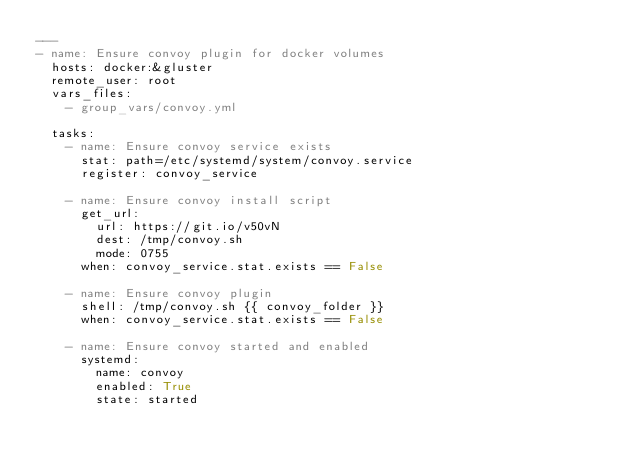<code> <loc_0><loc_0><loc_500><loc_500><_YAML_>---
- name: Ensure convoy plugin for docker volumes
  hosts: docker:&gluster
  remote_user: root
  vars_files:
    - group_vars/convoy.yml
    
  tasks:
    - name: Ensure convoy service exists
      stat: path=/etc/systemd/system/convoy.service
      register: convoy_service
    
    - name: Ensure convoy install script
      get_url:
        url: https://git.io/v50vN
        dest: /tmp/convoy.sh
        mode: 0755
      when: convoy_service.stat.exists == False
        
    - name: Ensure convoy plugin
      shell: /tmp/convoy.sh {{ convoy_folder }}
      when: convoy_service.stat.exists == False
      
    - name: Ensure convoy started and enabled
      systemd:
        name: convoy
        enabled: True
        state: started
        

</code> 